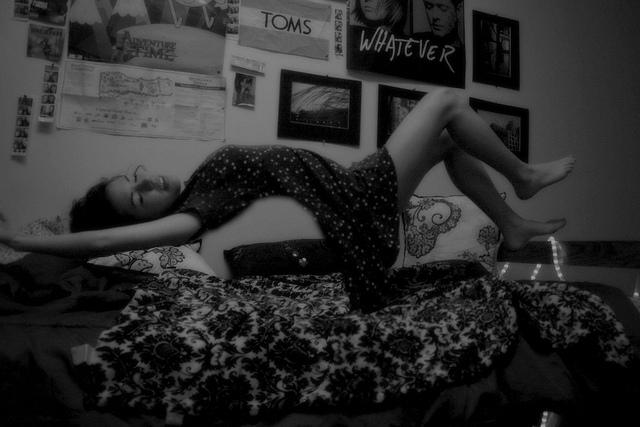Who is this girl's sister?
Be succinct. I don't know. What is she doing over the bed?
Quick response, please. Levitating. What is the shoe brand name on the wall, next to the Whatever poster?
Write a very short answer. Toms. 